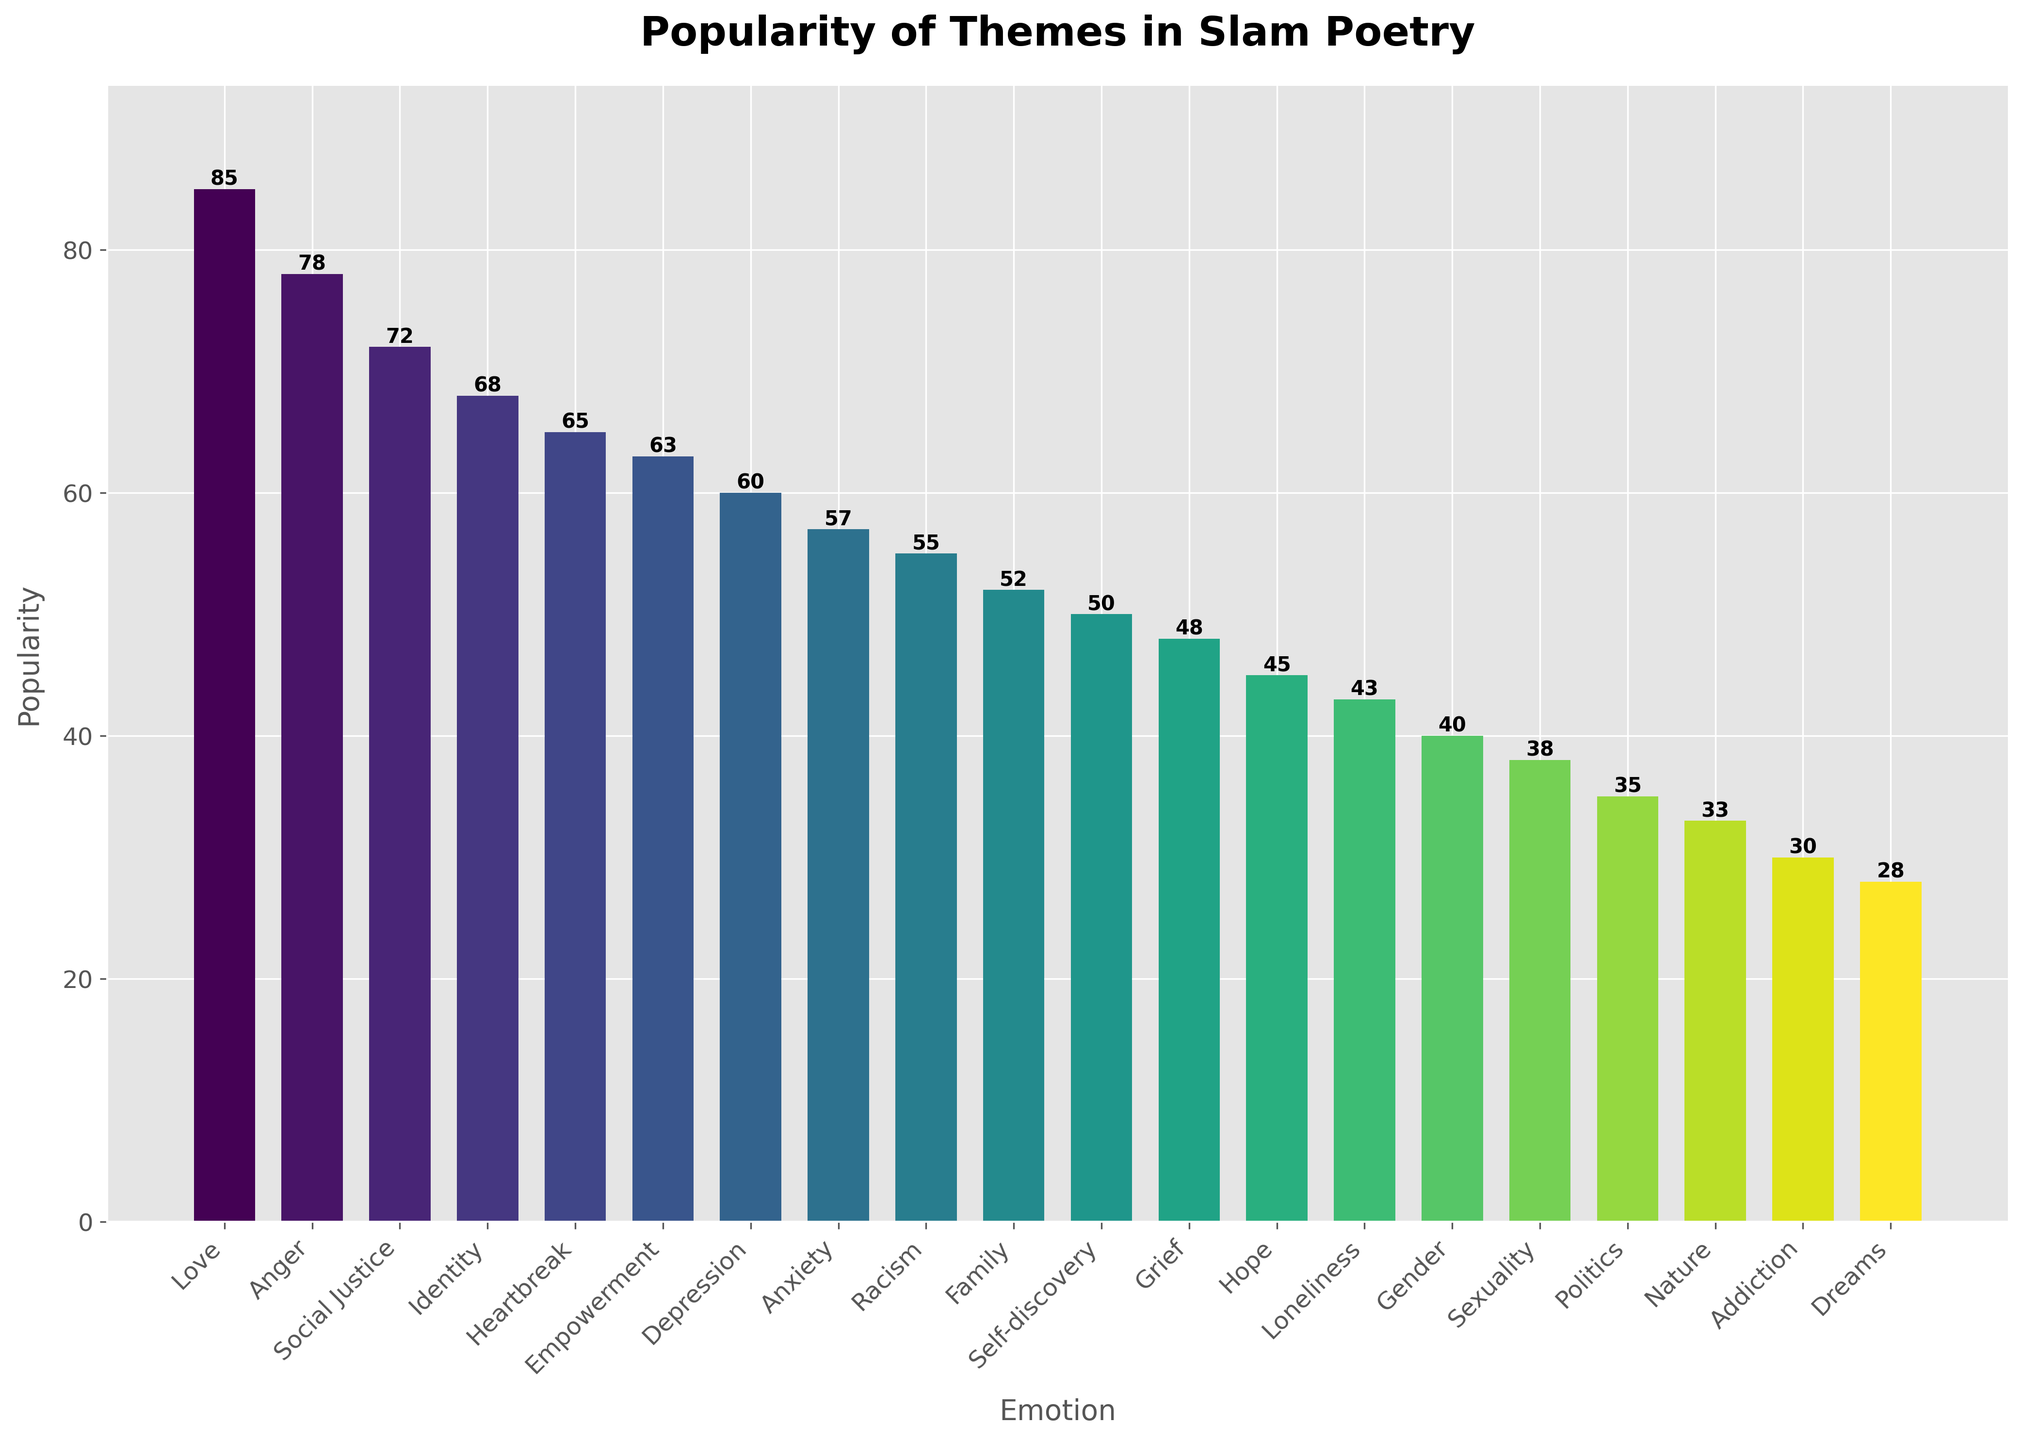Which theme has the highest popularity? By looking at the bar heights, the highest bar represents the theme 'Love' with a popularity of 85.
Answer: Love Which theme has the lowest popularity? The lowest bar represents the theme 'Dreams' with a popularity of 28.
Answer: Dreams What is the difference in popularity between 'Love' and 'Anger'? The popularity of 'Love' is 85 and 'Anger' is 78. The difference is 85 - 78 = 7.
Answer: 7 Which themes are more popular than 'Self-discovery'? By comparing the bars, 'Love', 'Anger', 'Social Justice', 'Identity', 'Heartbreak', 'Empowerment', 'Depression', 'Anxiety', 'Racism', and 'Family' have higher popularity than 'Self-discovery'.
Answer: Love, Anger, Social Justice, Identity, Heartbreak, Empowerment, Depression, Anxiety, Racism, Family How many themes have a popularity greater than 60? Count the bars with heights greater than 60. These themes are 'Love', 'Anger', 'Social Justice', 'Identity', 'Heartbreak', and 'Empowerment', totaling 6.
Answer: 6 What is the average popularity of the top 3 themes? The top 3 themes are 'Love' (85), 'Anger' (78), and 'Social Justice' (72). The average is (85 + 78 + 72) / 3 = 235 / 3 ≈ 78.3.
Answer: 78.3 What is the total popularity of the themes related to mental health ('Depression' and 'Anxiety')? The popularity of 'Depression' is 60 and 'Anxiety' is 57. The total is 60 + 57 = 117.
Answer: 117 Which themes share the same popularity value of exactly 60? By checking the bars, only 'Depression' has a popularity of exactly 60.
Answer: Depression Which theme related to personal identity has the highest popularity? Themes related to personal identity include 'Identity', 'Self-discovery', 'Gender', and 'Sexuality'. 'Identity' has the highest popularity with 68.
Answer: Identity 